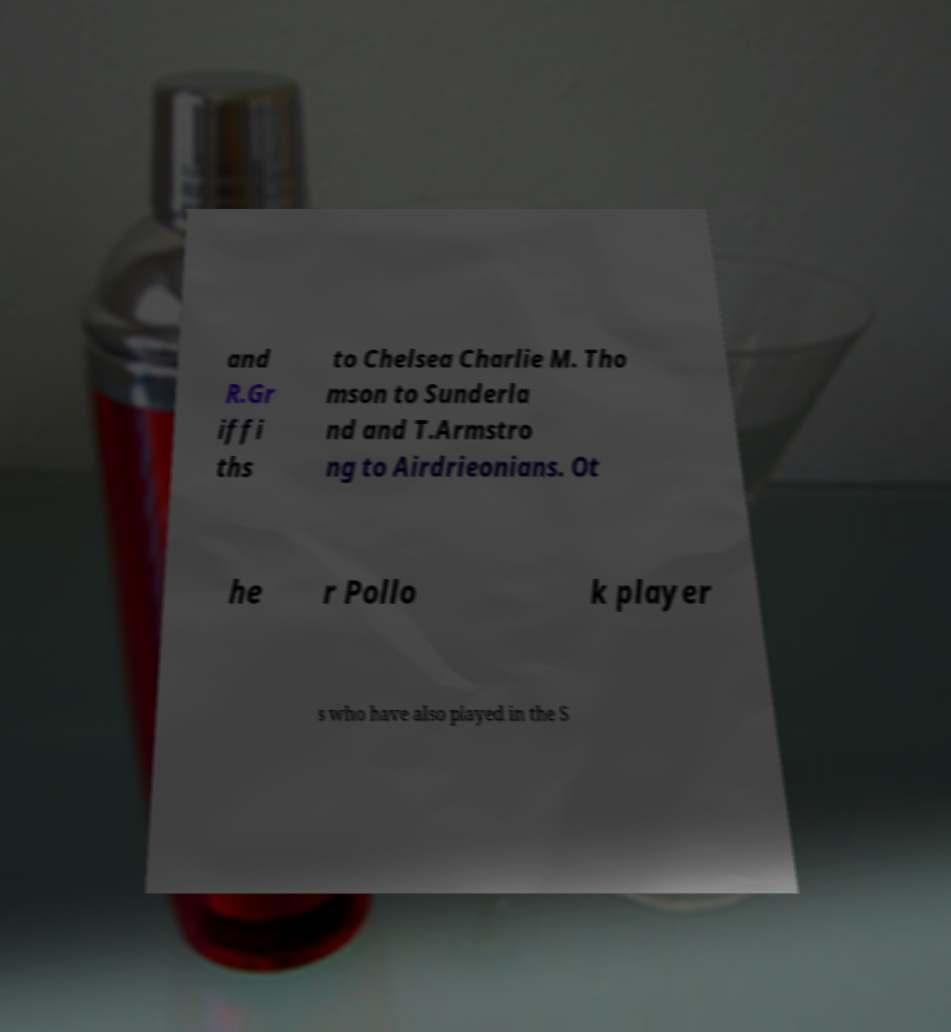Please identify and transcribe the text found in this image. and R.Gr iffi ths to Chelsea Charlie M. Tho mson to Sunderla nd and T.Armstro ng to Airdrieonians. Ot he r Pollo k player s who have also played in the S 